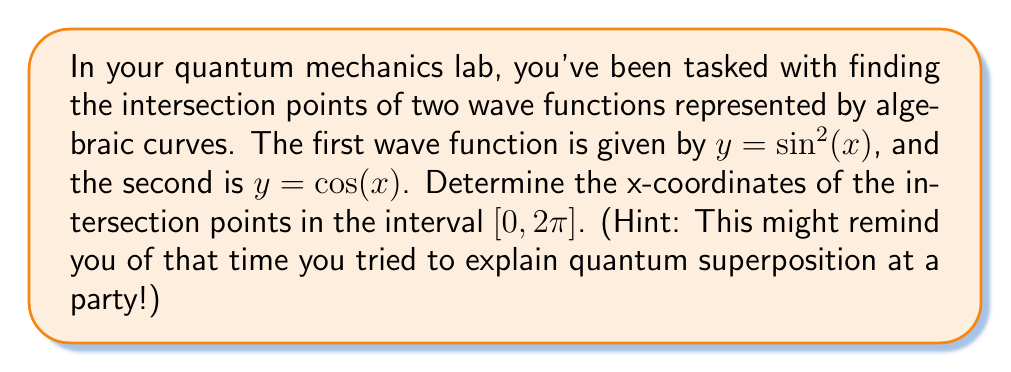Could you help me with this problem? Let's approach this step-by-step:

1) To find the intersection points, we need to solve the equation:
   $$\sin^2(x) = \cos(x)$$

2) We can rewrite this using the trigonometric identity $\sin^2(x) = 1 - \cos^2(x)$:
   $$1 - \cos^2(x) = \cos(x)$$

3) Rearranging the equation:
   $$\cos^2(x) + \cos(x) - 1 = 0$$

4) This is a quadratic equation in terms of $\cos(x)$. Let $u = \cos(x)$, then we have:
   $$u^2 + u - 1 = 0$$

5) We can solve this using the quadratic formula: $u = \frac{-b \pm \sqrt{b^2 - 4ac}}{2a}$
   $$u = \frac{-1 \pm \sqrt{1^2 - 4(1)(-1)}}{2(1)} = \frac{-1 \pm \sqrt{5}}{2}$$

6) The positive solution is: $u = \frac{-1 + \sqrt{5}}{2} \approx 0.618$
   The negative solution is: $u = \frac{-1 - \sqrt{5}}{2} \approx -1.618$

7) Since $\cos(x)$ is bounded between -1 and 1, we only consider the positive solution.

8) Therefore, we need to solve:
   $$\cos(x) = \frac{-1 + \sqrt{5}}{2}$$

9) In the interval $[0, 2\pi]$, this equation has two solutions:
   $$x_1 = \arccos(\frac{-1 + \sqrt{5}}{2}) \approx 0.904$$
   $$x_2 = 2\pi - \arccos(\frac{-1 + \sqrt{5}}{2}) \approx 5.379$$
Answer: $x \approx 0.904$ and $x \approx 5.379$ radians 